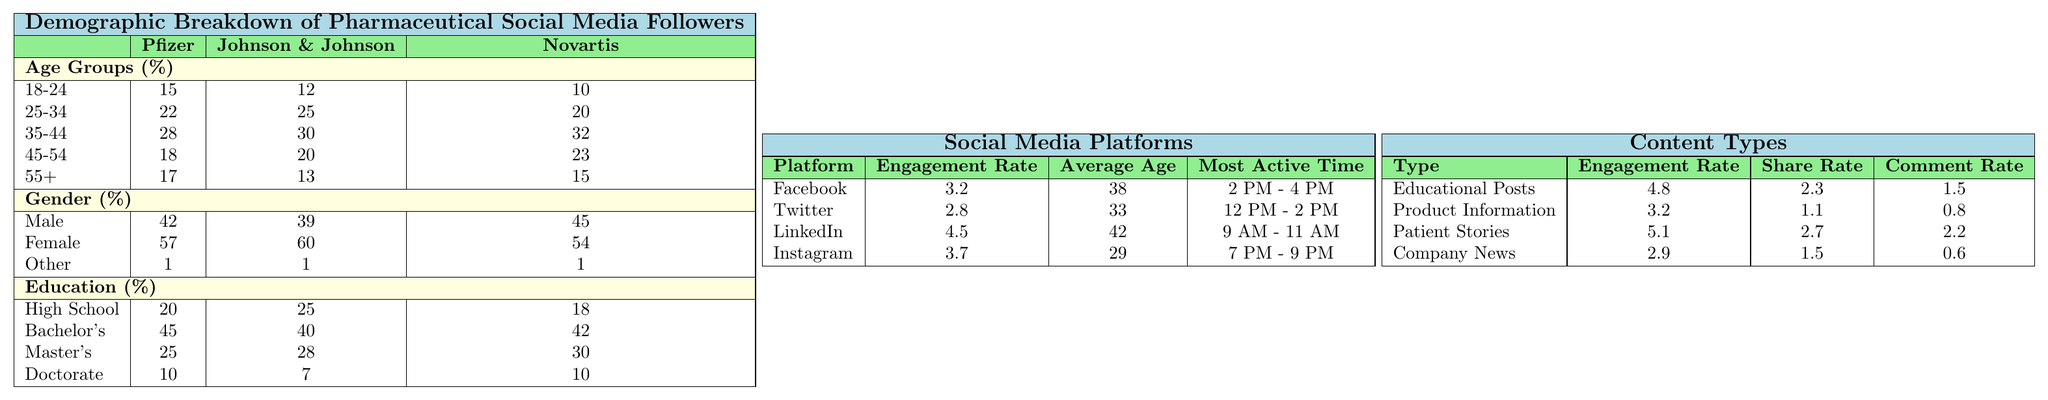What percentage of Pfizer's social media followers are aged 25-34? According to the table, Pfizer has 22% of its social media followers in the age group 25-34.
Answer: 22% What is the total percentage of female followers across all three pharmaceutical companies? For Pfizer, the female percentage is 57%, for Johnson & Johnson it is 60%, and for Novartis it is 54%. Adding these gives 57 + 60 + 54 = 171%. Since there are three companies, we calculate the average as 171 / 3 = 57%.
Answer: 57% Which pharmaceutical company has the highest percentage of male followers? Looking at the table, Novartis has the highest percentage of male followers at 45%.
Answer: 45% What is the average engagement rate for the content type "Patient Stories"? The engagement rate for "Patient Stories" is given as 5.1, so the average is simply 5.1 since there's only one data point.
Answer: 5.1 Is the most active time for Instagram followers in the evening? The table states that the most active time for Instagram is 7 PM - 9 PM, which is in the evening. Therefore, this statement is true.
Answer: Yes What is the difference in engagement rates between Facebook and LinkedIn? Facebook has an engagement rate of 3.2 and LinkedIn has 4.5. The difference is calculated as 4.5 - 3.2 = 1.3.
Answer: 1.3 What percentage of Novartis' followers have a Doctorate degree? The table indicates that 10% of Novartis' followers hold a Doctorate degree.
Answer: 10% Which age group has the highest percentage of followers for Johnson & Johnson? The highest percentage for Johnson & Johnson is in the age group 35-44, with 30%.
Answer: 30% What is the total share rate for "Educational Posts" and "Patient Stories"? The share rate for "Educational Posts" is 2.3 and for "Patient Stories" it is 2.7. Adding these gives 2.3 + 2.7 = 5.0.
Answer: 5.0 Which company has the lowest percentage of followers aged 18-24? From the table, Novartis has the lowest percentage of followers in the age group 18-24 at 10%.
Answer: 10% 